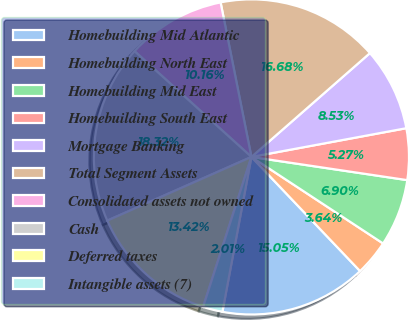Convert chart to OTSL. <chart><loc_0><loc_0><loc_500><loc_500><pie_chart><fcel>Homebuilding Mid Atlantic<fcel>Homebuilding North East<fcel>Homebuilding Mid East<fcel>Homebuilding South East<fcel>Mortgage Banking<fcel>Total Segment Assets<fcel>Consolidated assets not owned<fcel>Cash<fcel>Deferred taxes<fcel>Intangible assets (7)<nl><fcel>15.05%<fcel>3.64%<fcel>6.9%<fcel>5.27%<fcel>8.53%<fcel>16.68%<fcel>10.16%<fcel>18.32%<fcel>13.42%<fcel>2.01%<nl></chart> 